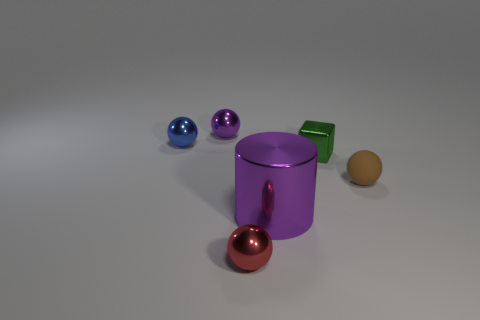Subtract all small blue shiny balls. How many balls are left? 3 Add 3 metallic blocks. How many objects exist? 9 Subtract all brown spheres. How many spheres are left? 3 Subtract all cylinders. How many objects are left? 5 Add 1 tiny green things. How many tiny green things are left? 2 Add 1 small yellow metallic objects. How many small yellow metallic objects exist? 1 Subtract 0 green balls. How many objects are left? 6 Subtract 2 balls. How many balls are left? 2 Subtract all purple balls. Subtract all brown blocks. How many balls are left? 3 Subtract all red blocks. How many brown spheres are left? 1 